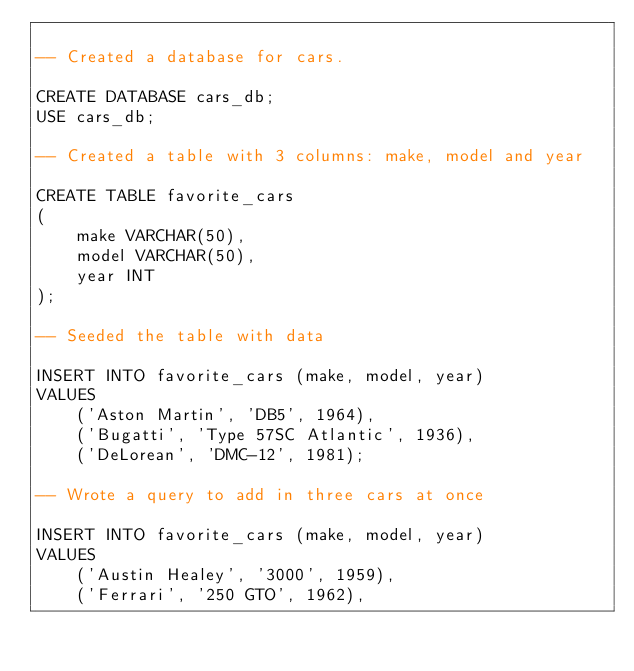Convert code to text. <code><loc_0><loc_0><loc_500><loc_500><_SQL_>
-- Created a database for cars.

CREATE DATABASE cars_db;
USE cars_db;

-- Created a table with 3 columns: make, model and year

CREATE TABLE favorite_cars
(
    make VARCHAR(50),
    model VARCHAR(50),
    year INT
);

-- Seeded the table with data

INSERT INTO favorite_cars (make, model, year)
VALUES 
    ('Aston Martin', 'DB5', 1964),
    ('Bugatti', 'Type 57SC Atlantic', 1936),
    ('DeLorean', 'DMC-12', 1981);

-- Wrote a query to add in three cars at once

INSERT INTO favorite_cars (make, model, year)
VALUES
    ('Austin Healey', '3000', 1959),
    ('Ferrari', '250 GTO', 1962),</code> 